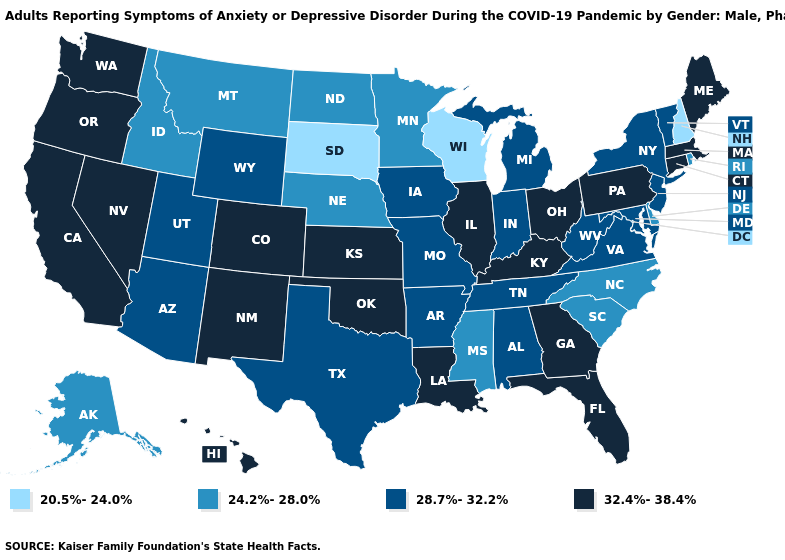Among the states that border West Virginia , does Pennsylvania have the highest value?
Write a very short answer. Yes. What is the lowest value in the Northeast?
Write a very short answer. 20.5%-24.0%. Does Indiana have a lower value than Missouri?
Give a very brief answer. No. Name the states that have a value in the range 24.2%-28.0%?
Give a very brief answer. Alaska, Delaware, Idaho, Minnesota, Mississippi, Montana, Nebraska, North Carolina, North Dakota, Rhode Island, South Carolina. Does the first symbol in the legend represent the smallest category?
Short answer required. Yes. Among the states that border Maryland , does Delaware have the lowest value?
Short answer required. Yes. What is the value of Utah?
Be succinct. 28.7%-32.2%. What is the highest value in the West ?
Quick response, please. 32.4%-38.4%. Name the states that have a value in the range 20.5%-24.0%?
Short answer required. New Hampshire, South Dakota, Wisconsin. What is the lowest value in the USA?
Write a very short answer. 20.5%-24.0%. What is the highest value in states that border West Virginia?
Write a very short answer. 32.4%-38.4%. What is the lowest value in the USA?
Give a very brief answer. 20.5%-24.0%. Name the states that have a value in the range 20.5%-24.0%?
Keep it brief. New Hampshire, South Dakota, Wisconsin. Name the states that have a value in the range 20.5%-24.0%?
Concise answer only. New Hampshire, South Dakota, Wisconsin. Among the states that border Idaho , which have the highest value?
Write a very short answer. Nevada, Oregon, Washington. 